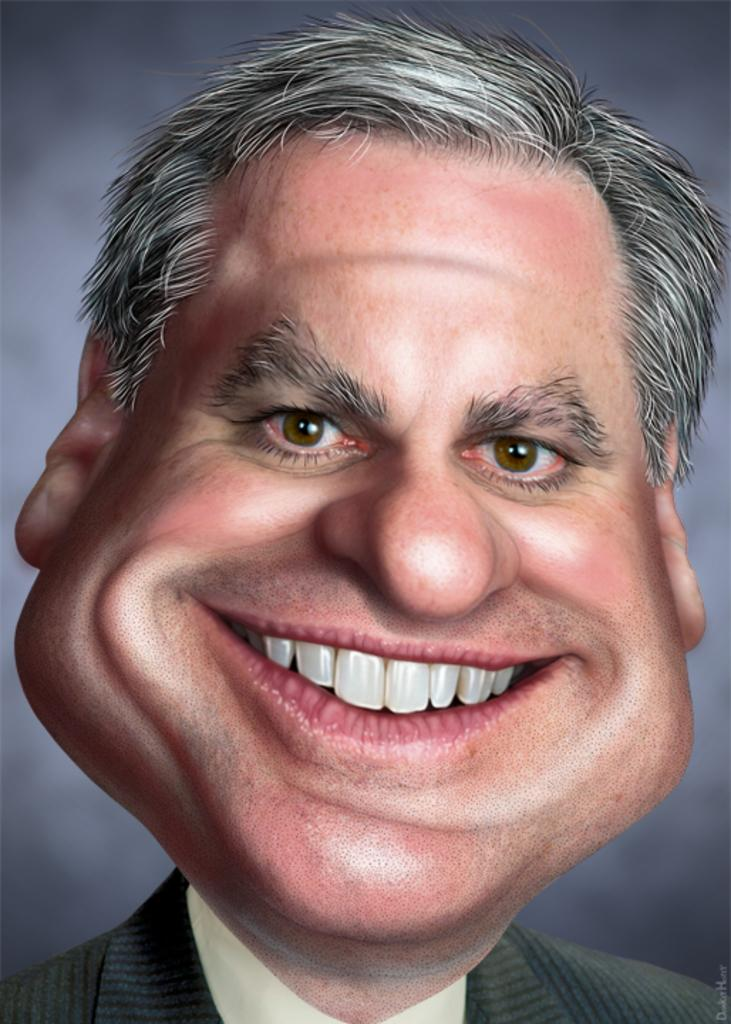What is the main subject of the image? There is a man in the image. What is the man's facial expression? The man is smiling. Can you describe the background of the image? The background of the image is blurred. What type of pies is the man baking in the image? There is no indication in the image that the man is baking pies, as the focus is on his facial expression and the blurred background. 